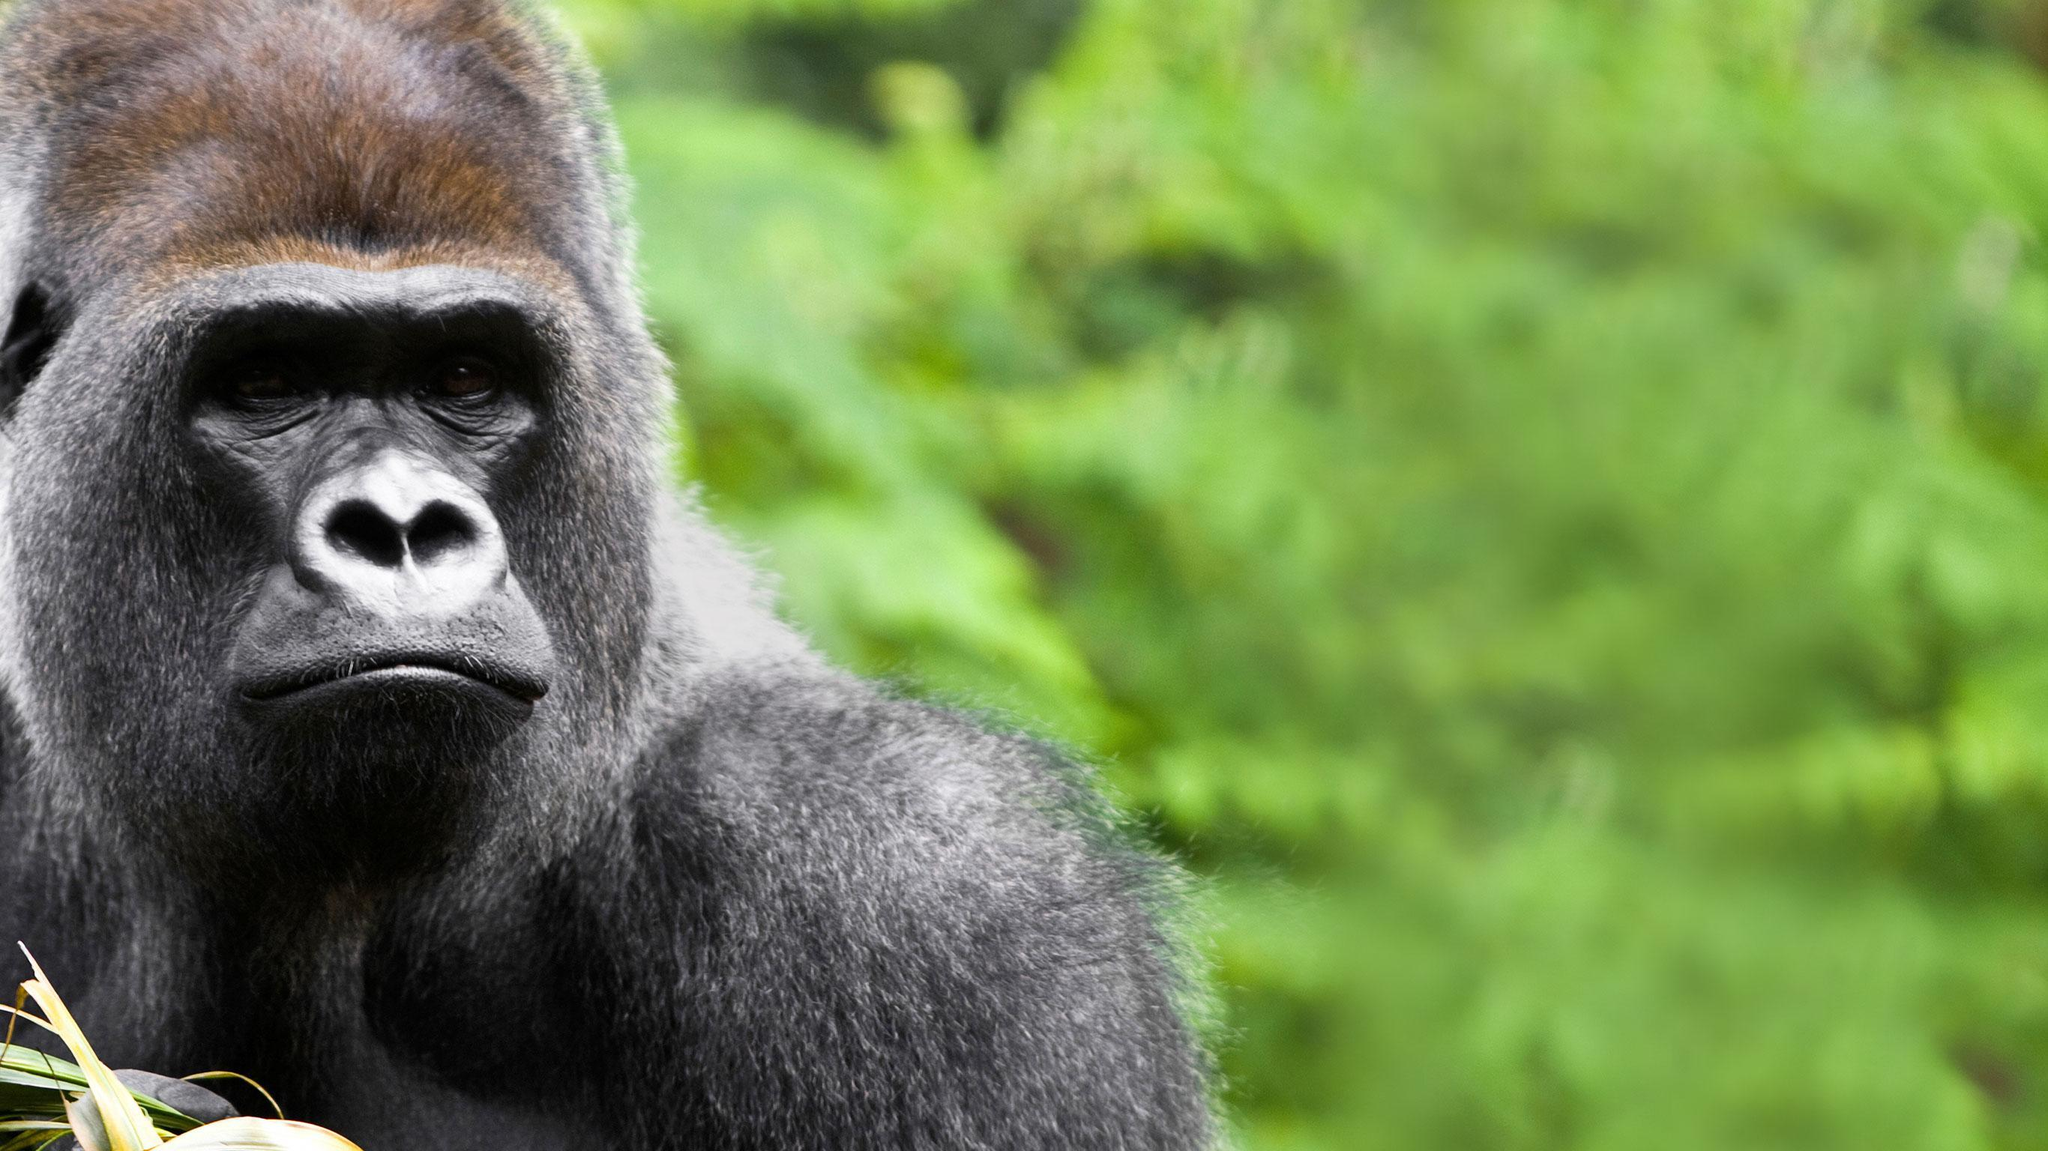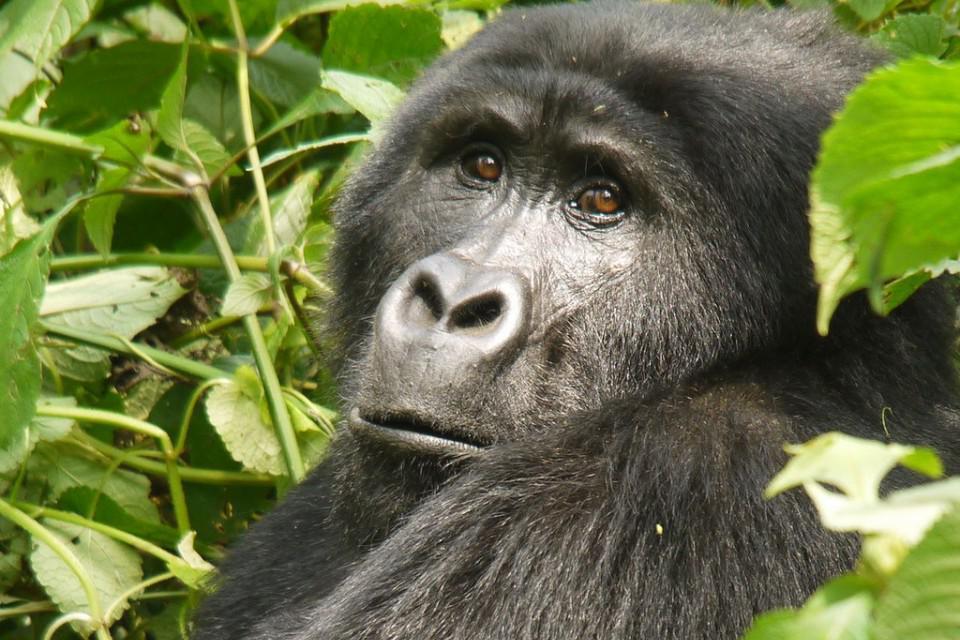The first image is the image on the left, the second image is the image on the right. Evaluate the accuracy of this statement regarding the images: "One image has a young ape along with an adult.". Is it true? Answer yes or no. No. The first image is the image on the left, the second image is the image on the right. Considering the images on both sides, is "There is a baby primate with an adult primate." valid? Answer yes or no. No. 